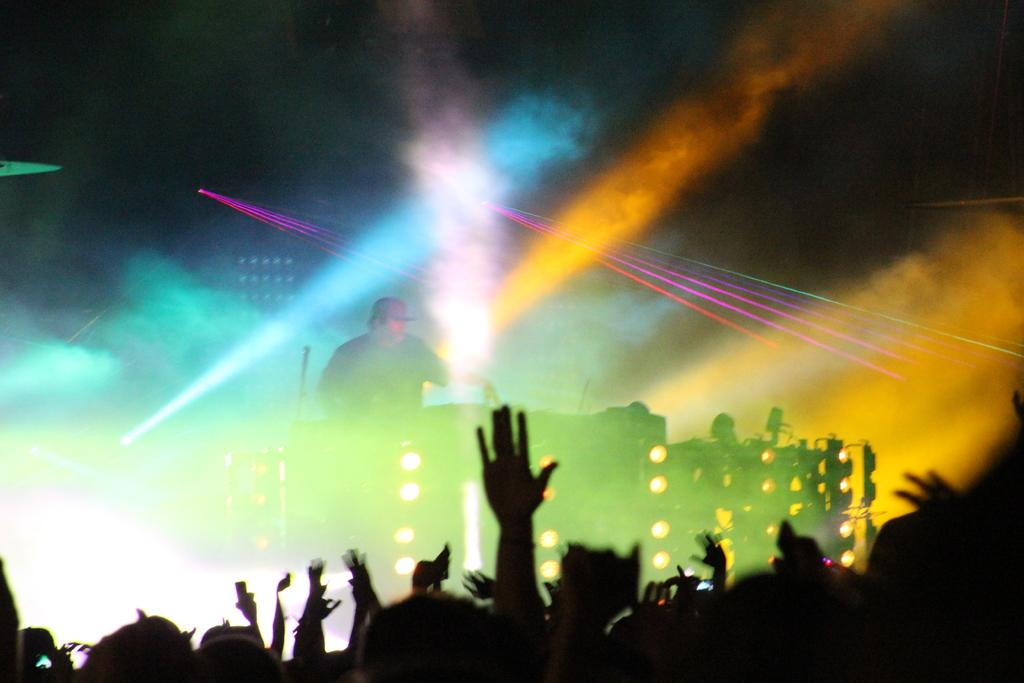What event is happening in the image? A concert is taking place in the image. Where are the people located in relation to the stage? People are present at the front of the stage. What can be seen in the image that might be used for illumination? There are lights visible in the image. Who is on the stage during the concert? A person is standing on the stage. What special effects are visible at the back of the stage? There are lights and smoke at the back of the stage. Can you see a bridge crossing a lake in the image? No, there is no bridge or lake present in the image. What is the level of fear among the audience members during the concert? The level of fear among the audience members cannot be determined from the image, as it does not provide information about their emotions. 